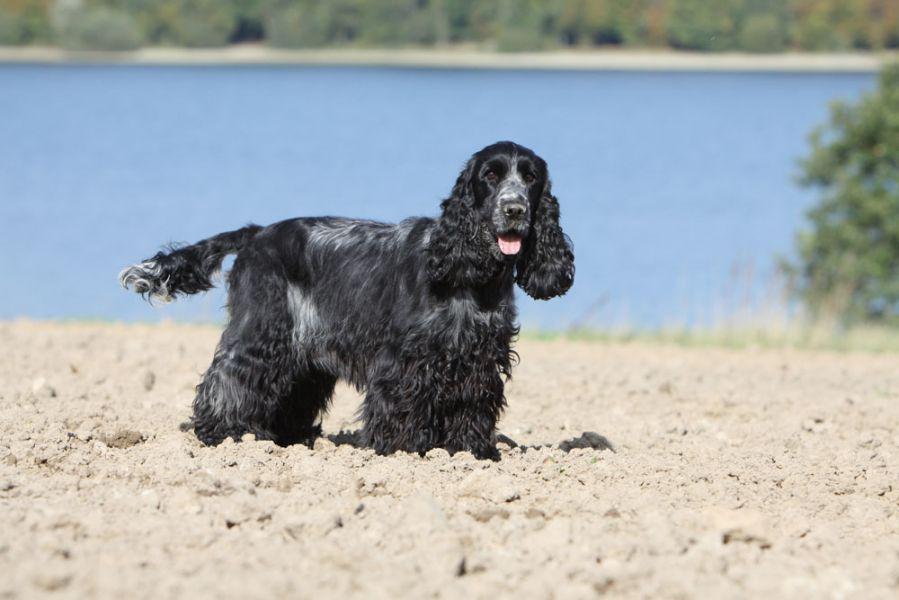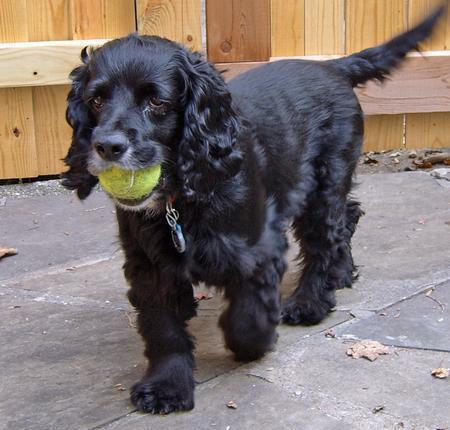The first image is the image on the left, the second image is the image on the right. Assess this claim about the two images: "The dog in the image on the left is on a leash.". Correct or not? Answer yes or no. No. The first image is the image on the left, the second image is the image on the right. For the images shown, is this caption "The left image contains one dog, a chocolate-brown spaniel with a leash extending from its neck." true? Answer yes or no. No. 